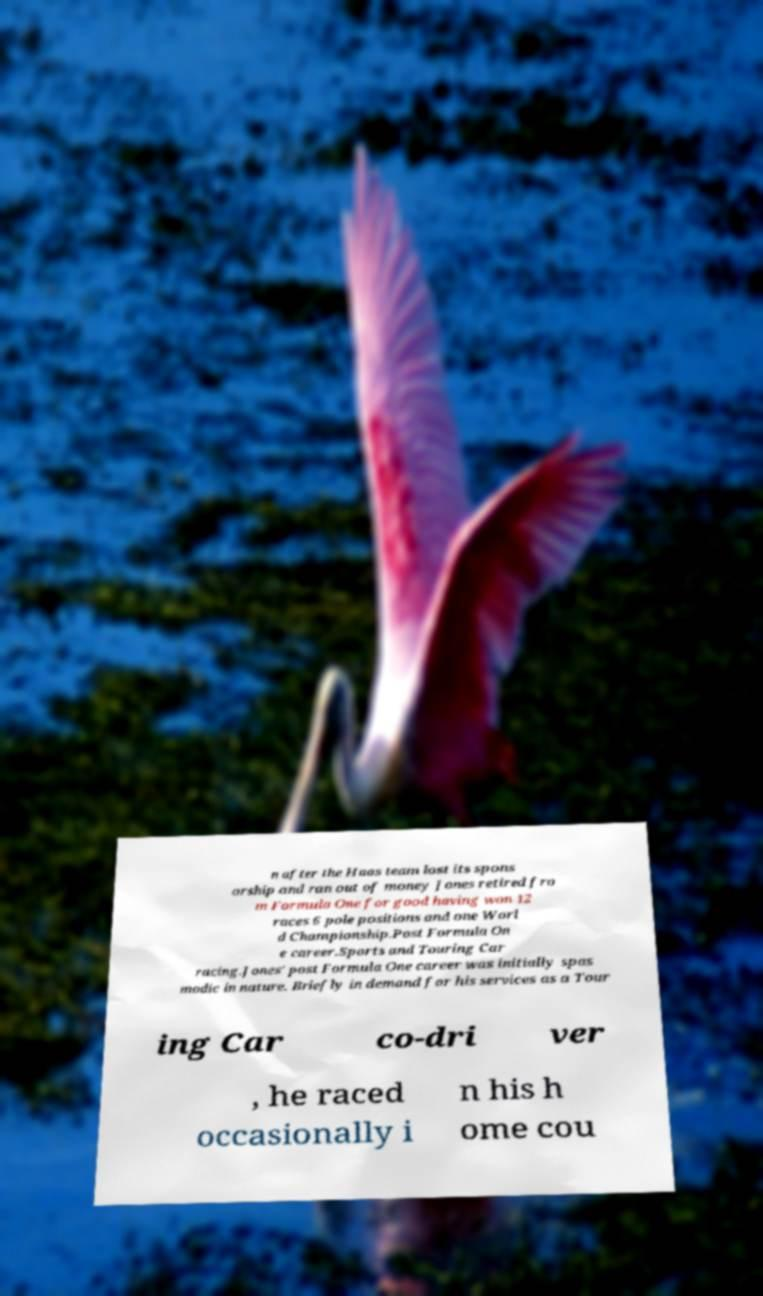Could you assist in decoding the text presented in this image and type it out clearly? n after the Haas team lost its spons orship and ran out of money Jones retired fro m Formula One for good having won 12 races 6 pole positions and one Worl d Championship.Post Formula On e career.Sports and Touring Car racing.Jones' post Formula One career was initially spas modic in nature. Briefly in demand for his services as a Tour ing Car co-dri ver , he raced occasionally i n his h ome cou 